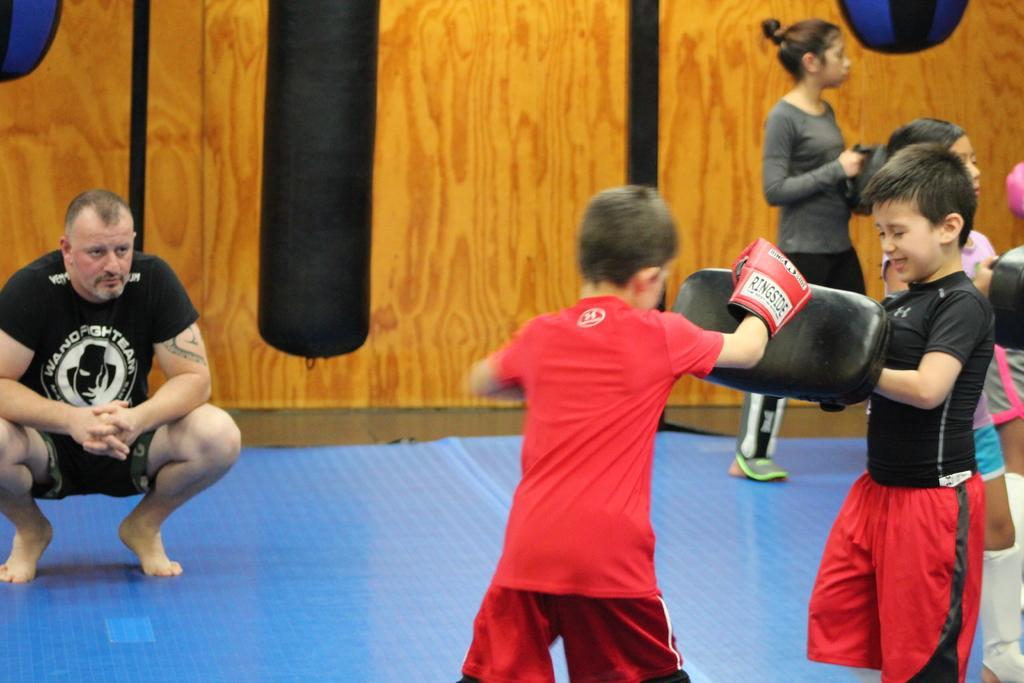In one or two sentences, can you explain what this image depicts? As we can see in the image there are few people here and there and there is a wall. 